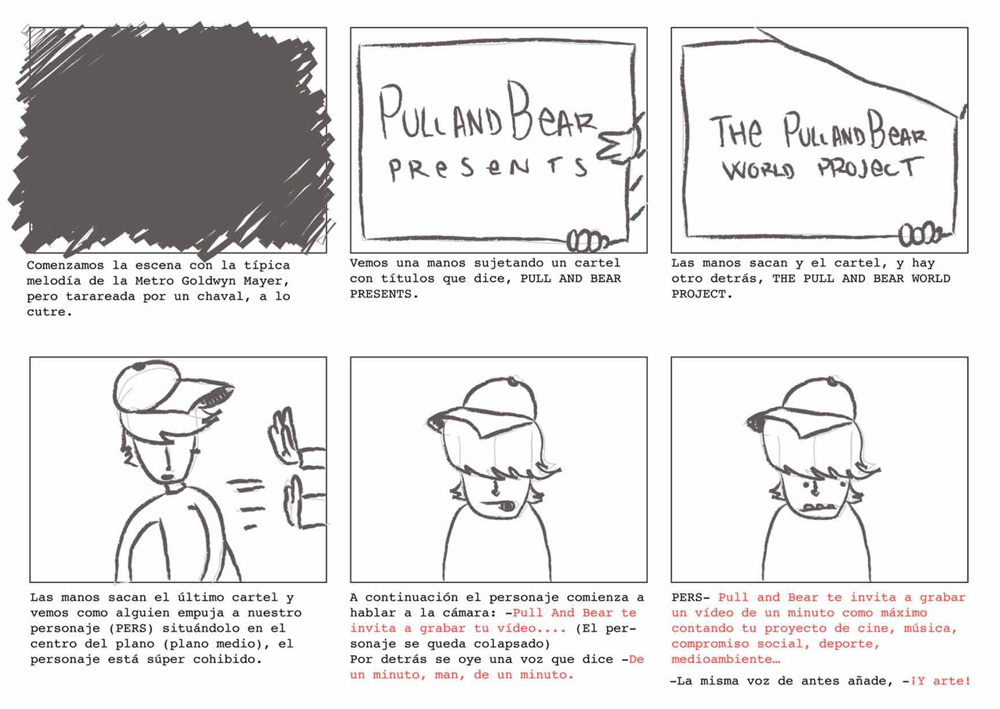Can you describe the setting and the style of the comic? The comic strip is set in a simplistic yet expressive style, with hand-drawn characters and minimalistic backgrounds that focus attention on the actions and expressions of the characters. The setting starts with a parody of the classic MGM intro but creatively transitions into a presentation scenario, blending humor with a contemporary edge, which is typical of underground or indie comic art. 